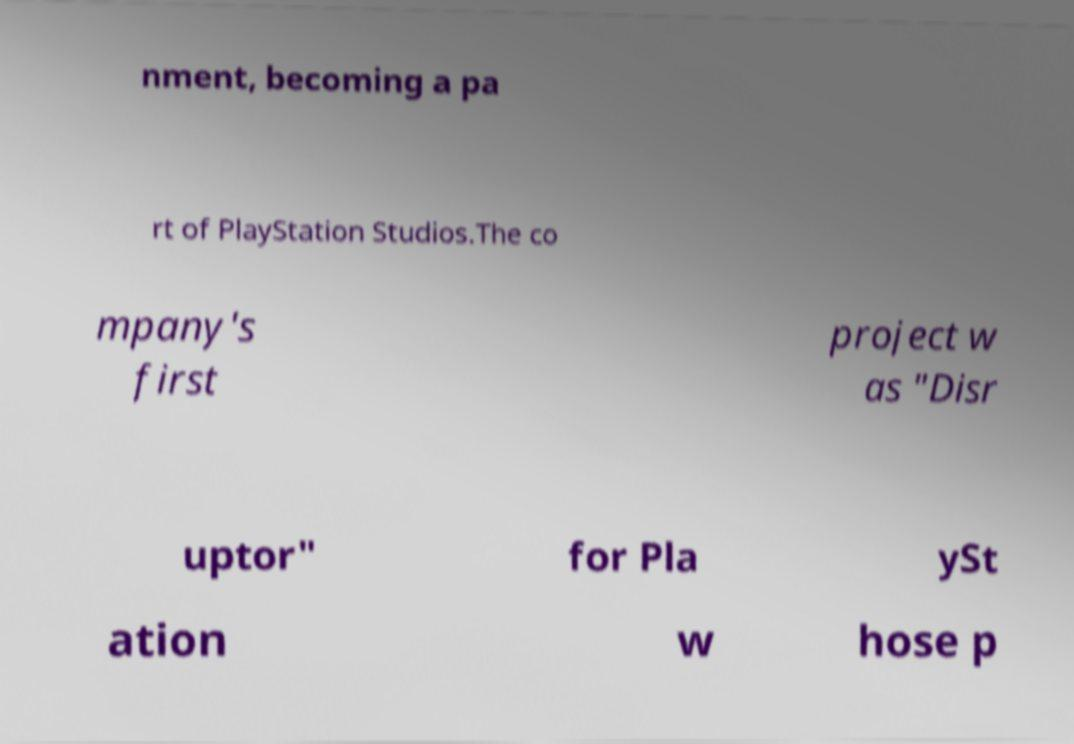Can you accurately transcribe the text from the provided image for me? nment, becoming a pa rt of PlayStation Studios.The co mpany's first project w as "Disr uptor" for Pla ySt ation w hose p 